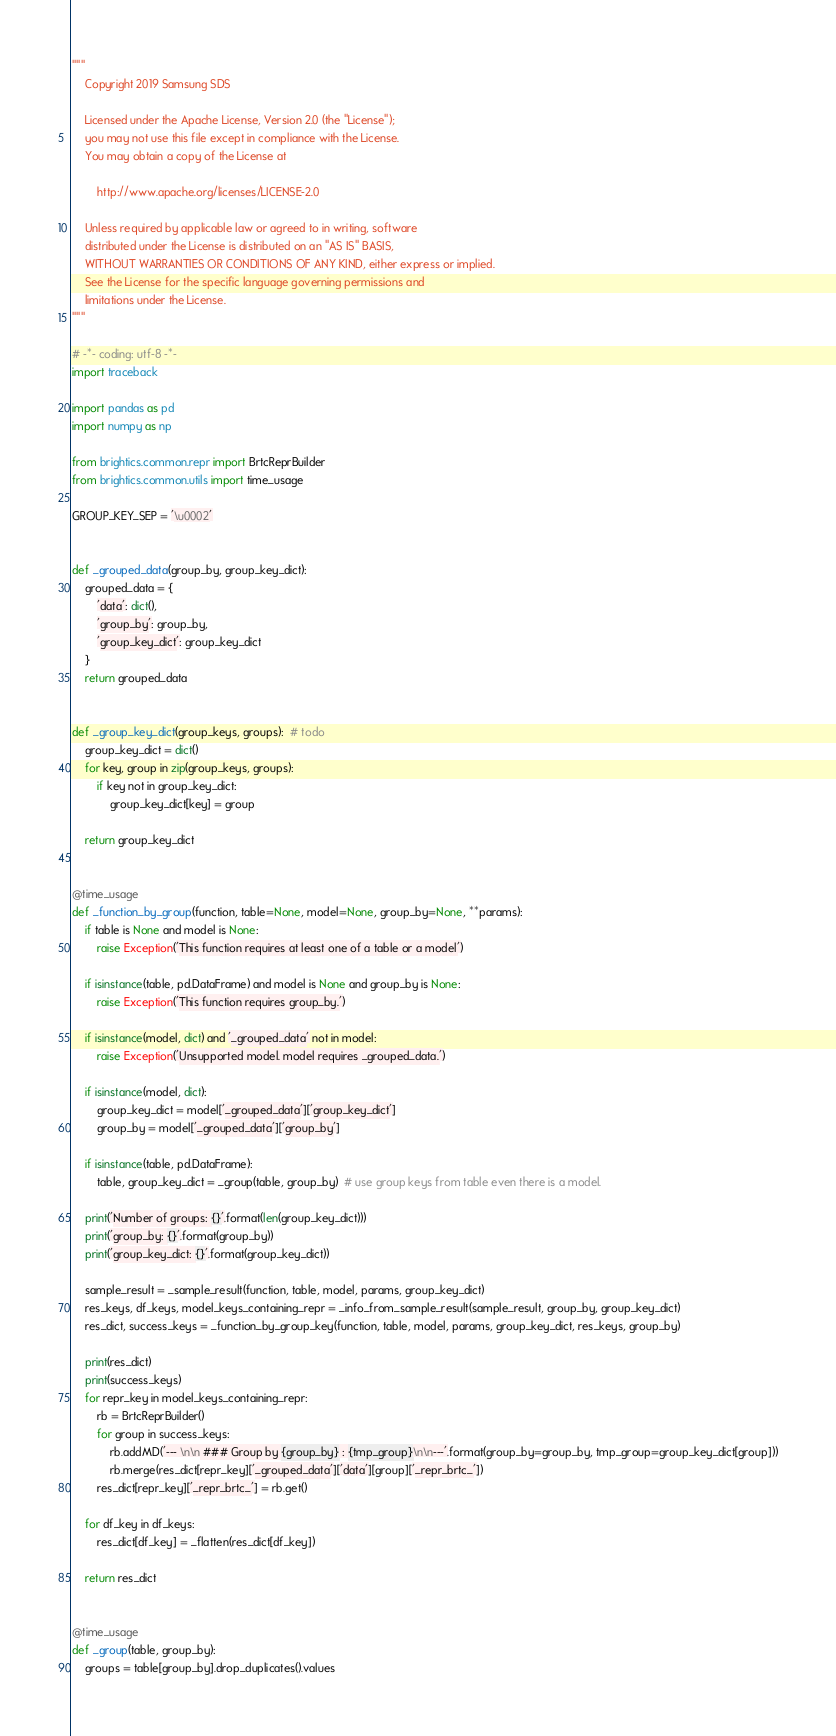Convert code to text. <code><loc_0><loc_0><loc_500><loc_500><_Python_>"""
    Copyright 2019 Samsung SDS
    
    Licensed under the Apache License, Version 2.0 (the "License");
    you may not use this file except in compliance with the License.
    You may obtain a copy of the License at
    
        http://www.apache.org/licenses/LICENSE-2.0
    
    Unless required by applicable law or agreed to in writing, software
    distributed under the License is distributed on an "AS IS" BASIS,
    WITHOUT WARRANTIES OR CONDITIONS OF ANY KIND, either express or implied.
    See the License for the specific language governing permissions and
    limitations under the License.
"""

# -*- coding: utf-8 -*-
import traceback

import pandas as pd
import numpy as np

from brightics.common.repr import BrtcReprBuilder
from brightics.common.utils import time_usage

GROUP_KEY_SEP = '\u0002'


def _grouped_data(group_by, group_key_dict):
    grouped_data = {
        'data': dict(),
        'group_by': group_by,
        'group_key_dict': group_key_dict
    }
    return grouped_data


def _group_key_dict(group_keys, groups):  # todo
    group_key_dict = dict()
    for key, group in zip(group_keys, groups):
        if key not in group_key_dict:
            group_key_dict[key] = group

    return group_key_dict


@time_usage
def _function_by_group(function, table=None, model=None, group_by=None, **params):
    if table is None and model is None:
        raise Exception('This function requires at least one of a table or a model')

    if isinstance(table, pd.DataFrame) and model is None and group_by is None:
        raise Exception('This function requires group_by.')

    if isinstance(model, dict) and '_grouped_data' not in model:
        raise Exception('Unsupported model. model requires _grouped_data.')

    if isinstance(model, dict):
        group_key_dict = model['_grouped_data']['group_key_dict']
        group_by = model['_grouped_data']['group_by']

    if isinstance(table, pd.DataFrame):
        table, group_key_dict = _group(table, group_by)  # use group keys from table even there is a model.

    print('Number of groups: {}'.format(len(group_key_dict)))
    print('group_by: {}'.format(group_by))
    print('group_key_dict: {}'.format(group_key_dict))

    sample_result = _sample_result(function, table, model, params, group_key_dict)
    res_keys, df_keys, model_keys_containing_repr = _info_from_sample_result(sample_result, group_by, group_key_dict)
    res_dict, success_keys = _function_by_group_key(function, table, model, params, group_key_dict, res_keys, group_by)

    print(res_dict)
    print(success_keys)
    for repr_key in model_keys_containing_repr:
        rb = BrtcReprBuilder()
        for group in success_keys:
            rb.addMD('--- \n\n ### Group by {group_by} : {tmp_group}\n\n---'.format(group_by=group_by, tmp_group=group_key_dict[group]))
            rb.merge(res_dict[repr_key]['_grouped_data']['data'][group]['_repr_brtc_'])
        res_dict[repr_key]['_repr_brtc_'] = rb.get()

    for df_key in df_keys:
        res_dict[df_key] = _flatten(res_dict[df_key])

    return res_dict


@time_usage
def _group(table, group_by):
    groups = table[group_by].drop_duplicates().values</code> 